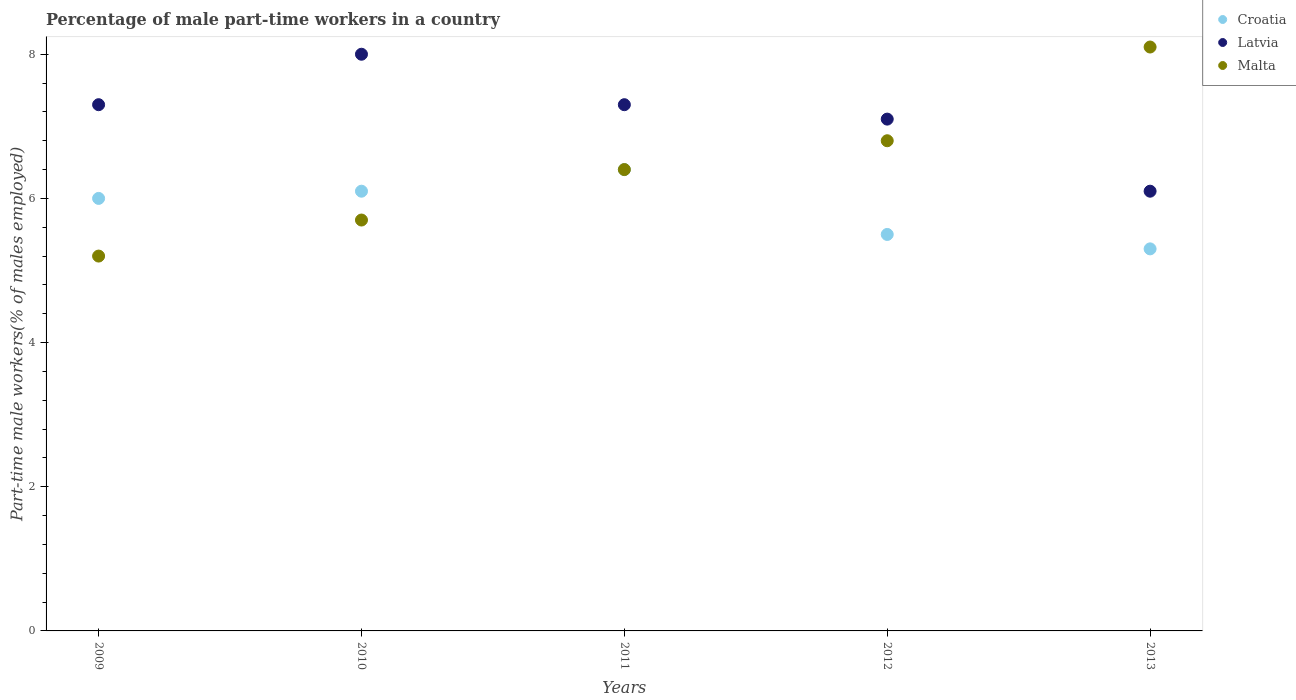What is the percentage of male part-time workers in Malta in 2012?
Offer a very short reply. 6.8. Across all years, what is the maximum percentage of male part-time workers in Malta?
Your response must be concise. 8.1. Across all years, what is the minimum percentage of male part-time workers in Latvia?
Provide a short and direct response. 6.1. In which year was the percentage of male part-time workers in Croatia minimum?
Offer a terse response. 2013. What is the total percentage of male part-time workers in Croatia in the graph?
Your response must be concise. 29.3. What is the difference between the percentage of male part-time workers in Malta in 2009 and that in 2011?
Give a very brief answer. -1.2. What is the difference between the percentage of male part-time workers in Malta in 2013 and the percentage of male part-time workers in Latvia in 2010?
Give a very brief answer. 0.1. What is the average percentage of male part-time workers in Malta per year?
Make the answer very short. 6.44. In the year 2011, what is the difference between the percentage of male part-time workers in Croatia and percentage of male part-time workers in Latvia?
Ensure brevity in your answer.  -0.9. In how many years, is the percentage of male part-time workers in Croatia greater than 6.4 %?
Give a very brief answer. 1. What is the ratio of the percentage of male part-time workers in Croatia in 2010 to that in 2012?
Your answer should be very brief. 1.11. What is the difference between the highest and the second highest percentage of male part-time workers in Croatia?
Your response must be concise. 0.3. What is the difference between the highest and the lowest percentage of male part-time workers in Croatia?
Your response must be concise. 1.1. In how many years, is the percentage of male part-time workers in Croatia greater than the average percentage of male part-time workers in Croatia taken over all years?
Your answer should be very brief. 3. Is the sum of the percentage of male part-time workers in Croatia in 2011 and 2013 greater than the maximum percentage of male part-time workers in Latvia across all years?
Ensure brevity in your answer.  Yes. Is it the case that in every year, the sum of the percentage of male part-time workers in Malta and percentage of male part-time workers in Latvia  is greater than the percentage of male part-time workers in Croatia?
Give a very brief answer. Yes. Does the percentage of male part-time workers in Latvia monotonically increase over the years?
Your response must be concise. No. Is the percentage of male part-time workers in Croatia strictly less than the percentage of male part-time workers in Malta over the years?
Ensure brevity in your answer.  No. Does the graph contain grids?
Provide a succinct answer. No. How many legend labels are there?
Your answer should be very brief. 3. How are the legend labels stacked?
Keep it short and to the point. Vertical. What is the title of the graph?
Offer a terse response. Percentage of male part-time workers in a country. What is the label or title of the Y-axis?
Your answer should be very brief. Part-time male workers(% of males employed). What is the Part-time male workers(% of males employed) in Latvia in 2009?
Your answer should be compact. 7.3. What is the Part-time male workers(% of males employed) of Malta in 2009?
Offer a terse response. 5.2. What is the Part-time male workers(% of males employed) in Croatia in 2010?
Keep it short and to the point. 6.1. What is the Part-time male workers(% of males employed) in Latvia in 2010?
Keep it short and to the point. 8. What is the Part-time male workers(% of males employed) of Malta in 2010?
Your answer should be compact. 5.7. What is the Part-time male workers(% of males employed) in Croatia in 2011?
Ensure brevity in your answer.  6.4. What is the Part-time male workers(% of males employed) of Latvia in 2011?
Ensure brevity in your answer.  7.3. What is the Part-time male workers(% of males employed) of Malta in 2011?
Your answer should be very brief. 6.4. What is the Part-time male workers(% of males employed) of Latvia in 2012?
Keep it short and to the point. 7.1. What is the Part-time male workers(% of males employed) of Malta in 2012?
Your answer should be compact. 6.8. What is the Part-time male workers(% of males employed) of Croatia in 2013?
Offer a very short reply. 5.3. What is the Part-time male workers(% of males employed) in Latvia in 2013?
Give a very brief answer. 6.1. What is the Part-time male workers(% of males employed) in Malta in 2013?
Offer a terse response. 8.1. Across all years, what is the maximum Part-time male workers(% of males employed) of Croatia?
Give a very brief answer. 6.4. Across all years, what is the maximum Part-time male workers(% of males employed) in Malta?
Make the answer very short. 8.1. Across all years, what is the minimum Part-time male workers(% of males employed) in Croatia?
Provide a succinct answer. 5.3. Across all years, what is the minimum Part-time male workers(% of males employed) in Latvia?
Your response must be concise. 6.1. Across all years, what is the minimum Part-time male workers(% of males employed) of Malta?
Your response must be concise. 5.2. What is the total Part-time male workers(% of males employed) in Croatia in the graph?
Offer a terse response. 29.3. What is the total Part-time male workers(% of males employed) in Latvia in the graph?
Give a very brief answer. 35.8. What is the total Part-time male workers(% of males employed) in Malta in the graph?
Offer a terse response. 32.2. What is the difference between the Part-time male workers(% of males employed) in Croatia in 2009 and that in 2010?
Your response must be concise. -0.1. What is the difference between the Part-time male workers(% of males employed) of Latvia in 2009 and that in 2010?
Your answer should be very brief. -0.7. What is the difference between the Part-time male workers(% of males employed) in Malta in 2009 and that in 2010?
Give a very brief answer. -0.5. What is the difference between the Part-time male workers(% of males employed) in Croatia in 2009 and that in 2011?
Keep it short and to the point. -0.4. What is the difference between the Part-time male workers(% of males employed) of Croatia in 2009 and that in 2012?
Provide a succinct answer. 0.5. What is the difference between the Part-time male workers(% of males employed) of Malta in 2009 and that in 2012?
Ensure brevity in your answer.  -1.6. What is the difference between the Part-time male workers(% of males employed) of Croatia in 2009 and that in 2013?
Offer a terse response. 0.7. What is the difference between the Part-time male workers(% of males employed) of Croatia in 2010 and that in 2011?
Your answer should be compact. -0.3. What is the difference between the Part-time male workers(% of males employed) of Malta in 2010 and that in 2011?
Offer a terse response. -0.7. What is the difference between the Part-time male workers(% of males employed) of Latvia in 2010 and that in 2012?
Offer a very short reply. 0.9. What is the difference between the Part-time male workers(% of males employed) in Malta in 2010 and that in 2012?
Your response must be concise. -1.1. What is the difference between the Part-time male workers(% of males employed) in Latvia in 2010 and that in 2013?
Make the answer very short. 1.9. What is the difference between the Part-time male workers(% of males employed) of Malta in 2010 and that in 2013?
Your answer should be compact. -2.4. What is the difference between the Part-time male workers(% of males employed) of Croatia in 2011 and that in 2013?
Keep it short and to the point. 1.1. What is the difference between the Part-time male workers(% of males employed) in Malta in 2011 and that in 2013?
Your answer should be very brief. -1.7. What is the difference between the Part-time male workers(% of males employed) in Malta in 2012 and that in 2013?
Make the answer very short. -1.3. What is the difference between the Part-time male workers(% of males employed) in Latvia in 2009 and the Part-time male workers(% of males employed) in Malta in 2010?
Your answer should be compact. 1.6. What is the difference between the Part-time male workers(% of males employed) of Croatia in 2009 and the Part-time male workers(% of males employed) of Latvia in 2011?
Offer a terse response. -1.3. What is the difference between the Part-time male workers(% of males employed) in Croatia in 2009 and the Part-time male workers(% of males employed) in Malta in 2011?
Provide a succinct answer. -0.4. What is the difference between the Part-time male workers(% of males employed) in Croatia in 2009 and the Part-time male workers(% of males employed) in Latvia in 2012?
Your answer should be very brief. -1.1. What is the difference between the Part-time male workers(% of males employed) of Croatia in 2009 and the Part-time male workers(% of males employed) of Malta in 2012?
Ensure brevity in your answer.  -0.8. What is the difference between the Part-time male workers(% of males employed) of Latvia in 2009 and the Part-time male workers(% of males employed) of Malta in 2012?
Give a very brief answer. 0.5. What is the difference between the Part-time male workers(% of males employed) in Croatia in 2009 and the Part-time male workers(% of males employed) in Latvia in 2013?
Offer a terse response. -0.1. What is the difference between the Part-time male workers(% of males employed) of Latvia in 2009 and the Part-time male workers(% of males employed) of Malta in 2013?
Offer a terse response. -0.8. What is the difference between the Part-time male workers(% of males employed) in Croatia in 2010 and the Part-time male workers(% of males employed) in Latvia in 2011?
Your answer should be very brief. -1.2. What is the difference between the Part-time male workers(% of males employed) of Croatia in 2010 and the Part-time male workers(% of males employed) of Malta in 2011?
Your answer should be very brief. -0.3. What is the difference between the Part-time male workers(% of males employed) of Latvia in 2010 and the Part-time male workers(% of males employed) of Malta in 2011?
Your response must be concise. 1.6. What is the difference between the Part-time male workers(% of males employed) in Croatia in 2010 and the Part-time male workers(% of males employed) in Latvia in 2012?
Make the answer very short. -1. What is the difference between the Part-time male workers(% of males employed) in Croatia in 2010 and the Part-time male workers(% of males employed) in Malta in 2012?
Provide a succinct answer. -0.7. What is the difference between the Part-time male workers(% of males employed) of Croatia in 2010 and the Part-time male workers(% of males employed) of Latvia in 2013?
Your answer should be compact. 0. What is the difference between the Part-time male workers(% of males employed) of Croatia in 2010 and the Part-time male workers(% of males employed) of Malta in 2013?
Provide a succinct answer. -2. What is the difference between the Part-time male workers(% of males employed) of Croatia in 2011 and the Part-time male workers(% of males employed) of Malta in 2012?
Provide a short and direct response. -0.4. What is the difference between the Part-time male workers(% of males employed) of Latvia in 2011 and the Part-time male workers(% of males employed) of Malta in 2012?
Keep it short and to the point. 0.5. What is the difference between the Part-time male workers(% of males employed) of Croatia in 2011 and the Part-time male workers(% of males employed) of Latvia in 2013?
Provide a succinct answer. 0.3. What is the difference between the Part-time male workers(% of males employed) in Croatia in 2011 and the Part-time male workers(% of males employed) in Malta in 2013?
Make the answer very short. -1.7. What is the difference between the Part-time male workers(% of males employed) in Latvia in 2011 and the Part-time male workers(% of males employed) in Malta in 2013?
Provide a short and direct response. -0.8. What is the difference between the Part-time male workers(% of males employed) of Croatia in 2012 and the Part-time male workers(% of males employed) of Latvia in 2013?
Ensure brevity in your answer.  -0.6. What is the difference between the Part-time male workers(% of males employed) in Croatia in 2012 and the Part-time male workers(% of males employed) in Malta in 2013?
Provide a short and direct response. -2.6. What is the average Part-time male workers(% of males employed) of Croatia per year?
Keep it short and to the point. 5.86. What is the average Part-time male workers(% of males employed) of Latvia per year?
Your response must be concise. 7.16. What is the average Part-time male workers(% of males employed) in Malta per year?
Your answer should be very brief. 6.44. In the year 2009, what is the difference between the Part-time male workers(% of males employed) in Croatia and Part-time male workers(% of males employed) in Latvia?
Your answer should be compact. -1.3. In the year 2011, what is the difference between the Part-time male workers(% of males employed) in Croatia and Part-time male workers(% of males employed) in Latvia?
Offer a very short reply. -0.9. In the year 2011, what is the difference between the Part-time male workers(% of males employed) in Croatia and Part-time male workers(% of males employed) in Malta?
Your answer should be very brief. 0. In the year 2012, what is the difference between the Part-time male workers(% of males employed) in Croatia and Part-time male workers(% of males employed) in Latvia?
Ensure brevity in your answer.  -1.6. In the year 2012, what is the difference between the Part-time male workers(% of males employed) of Latvia and Part-time male workers(% of males employed) of Malta?
Your answer should be very brief. 0.3. In the year 2013, what is the difference between the Part-time male workers(% of males employed) of Croatia and Part-time male workers(% of males employed) of Malta?
Your answer should be very brief. -2.8. In the year 2013, what is the difference between the Part-time male workers(% of males employed) in Latvia and Part-time male workers(% of males employed) in Malta?
Offer a very short reply. -2. What is the ratio of the Part-time male workers(% of males employed) of Croatia in 2009 to that in 2010?
Offer a very short reply. 0.98. What is the ratio of the Part-time male workers(% of males employed) in Latvia in 2009 to that in 2010?
Keep it short and to the point. 0.91. What is the ratio of the Part-time male workers(% of males employed) of Malta in 2009 to that in 2010?
Provide a short and direct response. 0.91. What is the ratio of the Part-time male workers(% of males employed) of Malta in 2009 to that in 2011?
Keep it short and to the point. 0.81. What is the ratio of the Part-time male workers(% of males employed) in Latvia in 2009 to that in 2012?
Your answer should be very brief. 1.03. What is the ratio of the Part-time male workers(% of males employed) in Malta in 2009 to that in 2012?
Offer a very short reply. 0.76. What is the ratio of the Part-time male workers(% of males employed) of Croatia in 2009 to that in 2013?
Offer a terse response. 1.13. What is the ratio of the Part-time male workers(% of males employed) of Latvia in 2009 to that in 2013?
Make the answer very short. 1.2. What is the ratio of the Part-time male workers(% of males employed) in Malta in 2009 to that in 2013?
Make the answer very short. 0.64. What is the ratio of the Part-time male workers(% of males employed) in Croatia in 2010 to that in 2011?
Your answer should be very brief. 0.95. What is the ratio of the Part-time male workers(% of males employed) in Latvia in 2010 to that in 2011?
Your answer should be compact. 1.1. What is the ratio of the Part-time male workers(% of males employed) in Malta in 2010 to that in 2011?
Keep it short and to the point. 0.89. What is the ratio of the Part-time male workers(% of males employed) in Croatia in 2010 to that in 2012?
Provide a succinct answer. 1.11. What is the ratio of the Part-time male workers(% of males employed) in Latvia in 2010 to that in 2012?
Provide a short and direct response. 1.13. What is the ratio of the Part-time male workers(% of males employed) in Malta in 2010 to that in 2012?
Make the answer very short. 0.84. What is the ratio of the Part-time male workers(% of males employed) in Croatia in 2010 to that in 2013?
Make the answer very short. 1.15. What is the ratio of the Part-time male workers(% of males employed) of Latvia in 2010 to that in 2013?
Ensure brevity in your answer.  1.31. What is the ratio of the Part-time male workers(% of males employed) of Malta in 2010 to that in 2013?
Your answer should be compact. 0.7. What is the ratio of the Part-time male workers(% of males employed) in Croatia in 2011 to that in 2012?
Offer a very short reply. 1.16. What is the ratio of the Part-time male workers(% of males employed) of Latvia in 2011 to that in 2012?
Provide a short and direct response. 1.03. What is the ratio of the Part-time male workers(% of males employed) in Malta in 2011 to that in 2012?
Give a very brief answer. 0.94. What is the ratio of the Part-time male workers(% of males employed) in Croatia in 2011 to that in 2013?
Provide a short and direct response. 1.21. What is the ratio of the Part-time male workers(% of males employed) in Latvia in 2011 to that in 2013?
Offer a terse response. 1.2. What is the ratio of the Part-time male workers(% of males employed) in Malta in 2011 to that in 2013?
Your answer should be very brief. 0.79. What is the ratio of the Part-time male workers(% of males employed) in Croatia in 2012 to that in 2013?
Make the answer very short. 1.04. What is the ratio of the Part-time male workers(% of males employed) in Latvia in 2012 to that in 2013?
Make the answer very short. 1.16. What is the ratio of the Part-time male workers(% of males employed) in Malta in 2012 to that in 2013?
Provide a succinct answer. 0.84. What is the difference between the highest and the second highest Part-time male workers(% of males employed) of Croatia?
Provide a succinct answer. 0.3. What is the difference between the highest and the second highest Part-time male workers(% of males employed) of Latvia?
Offer a terse response. 0.7. What is the difference between the highest and the second highest Part-time male workers(% of males employed) in Malta?
Your answer should be compact. 1.3. What is the difference between the highest and the lowest Part-time male workers(% of males employed) of Croatia?
Provide a succinct answer. 1.1. What is the difference between the highest and the lowest Part-time male workers(% of males employed) in Latvia?
Make the answer very short. 1.9. 